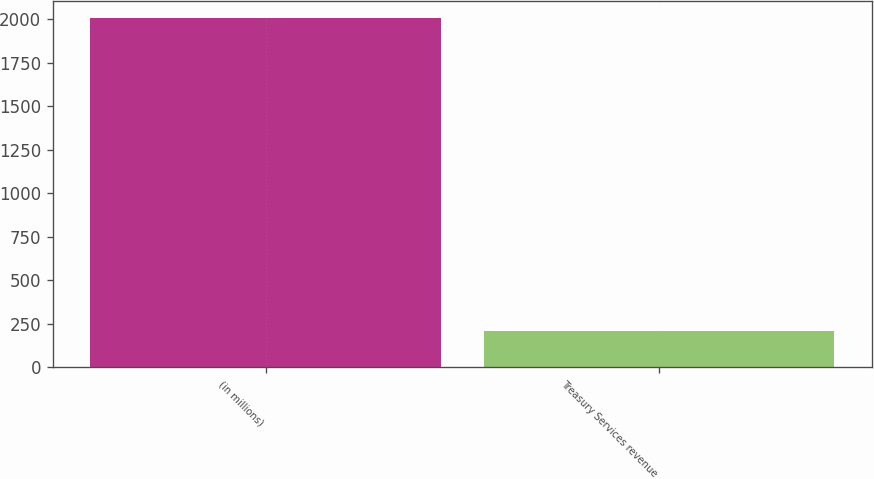<chart> <loc_0><loc_0><loc_500><loc_500><bar_chart><fcel>(in millions)<fcel>Treasury Services revenue<nl><fcel>2006<fcel>207<nl></chart> 